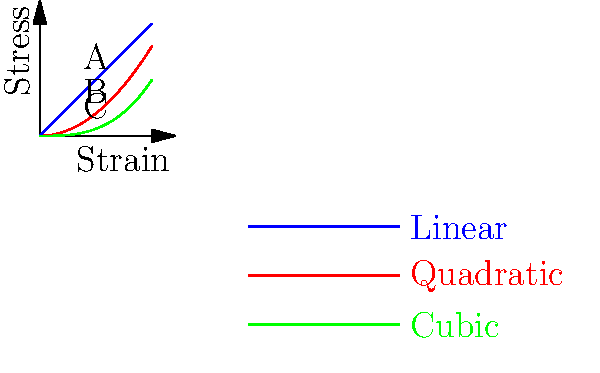In computational models of bone remodeling, stress-strain relationships are often simplified. The graph shows three different stress-strain curves (linear, quadratic, and cubic) that could be used to model bone behavior. Which of these models is most likely to underestimate fracture risk in real bone tissue, and why might this limitation arise from the philosophical perspective of model simplification? To answer this question, we need to consider the implications of model simplification in the context of bone remodeling:

1. The linear model (A) assumes a constant relationship between stress and strain. This is the simplest model but fails to capture the complex behavior of bone tissue.

2. The quadratic model (B) introduces some non-linearity, allowing for a more nuanced representation of bone behavior under stress.

3. The cubic model (C) provides the most complex relationship among the three, potentially capturing more subtle aspects of bone deformation.

From a philosophical perspective, we need to consider the trade-off between simplicity and accuracy in scientific models:

4. Simplification is often necessary to make models computationally tractable and easier to interpret. However, oversimplification can lead to inaccurate predictions.

5. The linear model (A) is the most simplified representation. While it may be useful for basic calculations, it fails to capture the non-linear behavior of bone tissue under high stress.

6. By assuming a linear relationship, model A underestimates the stress at higher strain levels compared to the other models. This means it would predict lower stress levels for a given strain, potentially underestimating the risk of fracture.

7. The limitation arises from the philosophical challenge of balancing model simplicity with accurate representation of reality. The linear model sacrifices accuracy for simplicity, which in this case could lead to potentially dangerous underestimations of fracture risk.

8. From an epistemological standpoint, this example illustrates how the choice of mathematical representation can significantly impact our understanding and predictions of physical phenomena, highlighting the need for critical analysis of model assumptions in scientific practice.
Answer: The linear model (A), as it oversimplifies bone behavior, underestimating stress at high strain levels. 